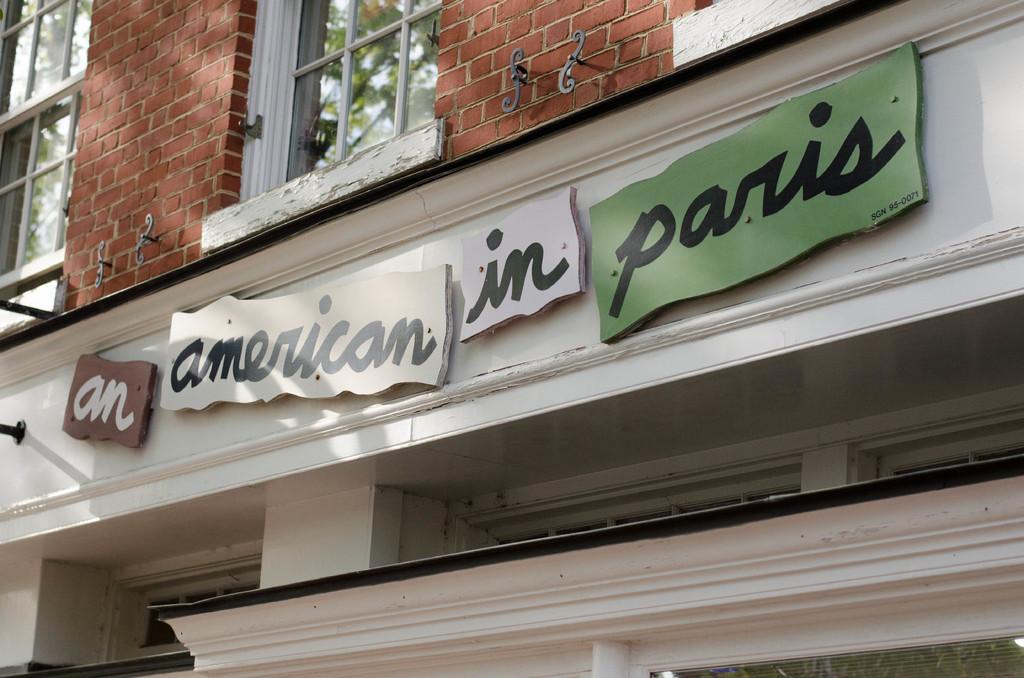Can you describe this image briefly? In this image we can see a building, on the building there are some boards with text, also we can see the windows, through the windows we can see the trees. 